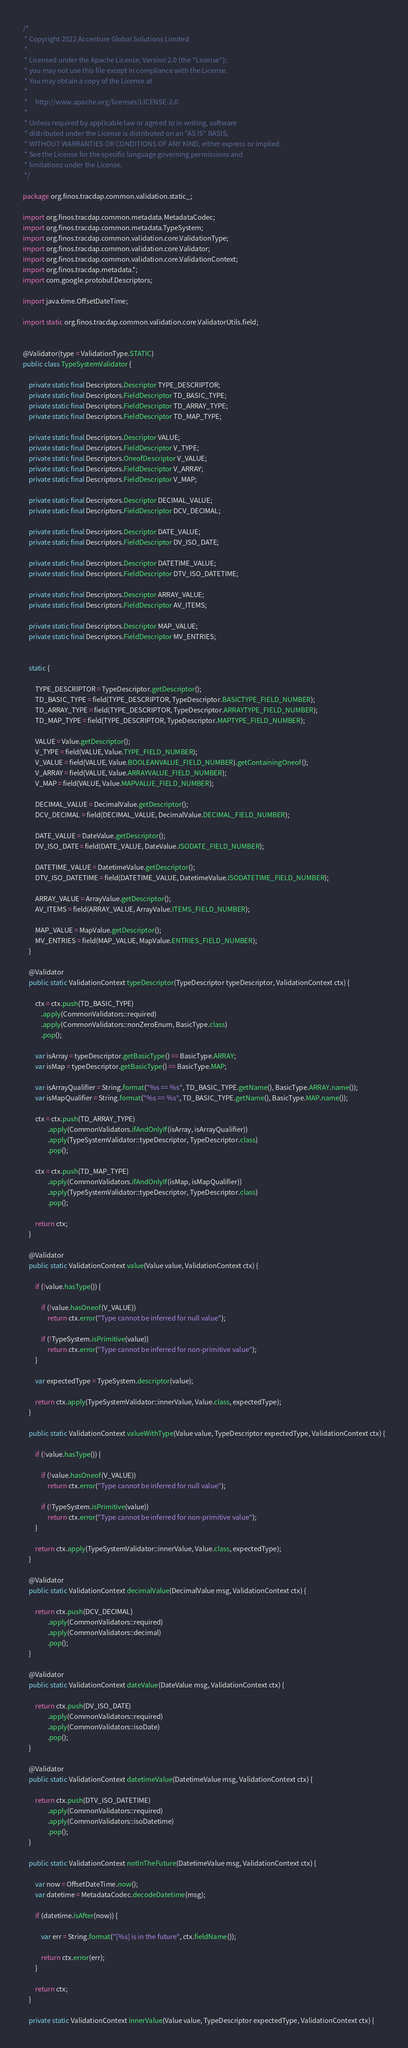Convert code to text. <code><loc_0><loc_0><loc_500><loc_500><_Java_>/*
 * Copyright 2022 Accenture Global Solutions Limited
 *
 * Licensed under the Apache License, Version 2.0 (the "License");
 * you may not use this file except in compliance with the License.
 * You may obtain a copy of the License at
 *
 *     http://www.apache.org/licenses/LICENSE-2.0
 *
 * Unless required by applicable law or agreed to in writing, software
 * distributed under the License is distributed on an "AS IS" BASIS,
 * WITHOUT WARRANTIES OR CONDITIONS OF ANY KIND, either express or implied.
 * See the License for the specific language governing permissions and
 * limitations under the License.
 */

package org.finos.tracdap.common.validation.static_;

import org.finos.tracdap.common.metadata.MetadataCodec;
import org.finos.tracdap.common.metadata.TypeSystem;
import org.finos.tracdap.common.validation.core.ValidationType;
import org.finos.tracdap.common.validation.core.Validator;
import org.finos.tracdap.common.validation.core.ValidationContext;
import org.finos.tracdap.metadata.*;
import com.google.protobuf.Descriptors;

import java.time.OffsetDateTime;

import static org.finos.tracdap.common.validation.core.ValidatorUtils.field;


@Validator(type = ValidationType.STATIC)
public class TypeSystemValidator {

    private static final Descriptors.Descriptor TYPE_DESCRIPTOR;
    private static final Descriptors.FieldDescriptor TD_BASIC_TYPE;
    private static final Descriptors.FieldDescriptor TD_ARRAY_TYPE;
    private static final Descriptors.FieldDescriptor TD_MAP_TYPE;

    private static final Descriptors.Descriptor VALUE;
    private static final Descriptors.FieldDescriptor V_TYPE;
    private static final Descriptors.OneofDescriptor V_VALUE;
    private static final Descriptors.FieldDescriptor V_ARRAY;
    private static final Descriptors.FieldDescriptor V_MAP;

    private static final Descriptors.Descriptor DECIMAL_VALUE;
    private static final Descriptors.FieldDescriptor DCV_DECIMAL;

    private static final Descriptors.Descriptor DATE_VALUE;
    private static final Descriptors.FieldDescriptor DV_ISO_DATE;

    private static final Descriptors.Descriptor DATETIME_VALUE;
    private static final Descriptors.FieldDescriptor DTV_ISO_DATETIME;

    private static final Descriptors.Descriptor ARRAY_VALUE;
    private static final Descriptors.FieldDescriptor AV_ITEMS;

    private static final Descriptors.Descriptor MAP_VALUE;
    private static final Descriptors.FieldDescriptor MV_ENTRIES;


    static {

        TYPE_DESCRIPTOR = TypeDescriptor.getDescriptor();
        TD_BASIC_TYPE = field(TYPE_DESCRIPTOR, TypeDescriptor.BASICTYPE_FIELD_NUMBER);
        TD_ARRAY_TYPE = field(TYPE_DESCRIPTOR, TypeDescriptor.ARRAYTYPE_FIELD_NUMBER);
        TD_MAP_TYPE = field(TYPE_DESCRIPTOR, TypeDescriptor.MAPTYPE_FIELD_NUMBER);

        VALUE = Value.getDescriptor();
        V_TYPE = field(VALUE, Value.TYPE_FIELD_NUMBER);
        V_VALUE = field(VALUE, Value.BOOLEANVALUE_FIELD_NUMBER).getContainingOneof();
        V_ARRAY = field(VALUE, Value.ARRAYVALUE_FIELD_NUMBER);
        V_MAP = field(VALUE, Value.MAPVALUE_FIELD_NUMBER);

        DECIMAL_VALUE = DecimalValue.getDescriptor();
        DCV_DECIMAL = field(DECIMAL_VALUE, DecimalValue.DECIMAL_FIELD_NUMBER);

        DATE_VALUE = DateValue.getDescriptor();
        DV_ISO_DATE = field(DATE_VALUE, DateValue.ISODATE_FIELD_NUMBER);

        DATETIME_VALUE = DatetimeValue.getDescriptor();
        DTV_ISO_DATETIME = field(DATETIME_VALUE, DatetimeValue.ISODATETIME_FIELD_NUMBER);

        ARRAY_VALUE = ArrayValue.getDescriptor();
        AV_ITEMS = field(ARRAY_VALUE, ArrayValue.ITEMS_FIELD_NUMBER);

        MAP_VALUE = MapValue.getDescriptor();
        MV_ENTRIES = field(MAP_VALUE, MapValue.ENTRIES_FIELD_NUMBER);
    }

    @Validator
    public static ValidationContext typeDescriptor(TypeDescriptor typeDescriptor, ValidationContext ctx) {

        ctx = ctx.push(TD_BASIC_TYPE)
            .apply(CommonValidators::required)
            .apply(CommonValidators::nonZeroEnum, BasicType.class)
            .pop();

        var isArray = typeDescriptor.getBasicType() == BasicType.ARRAY;
        var isMap = typeDescriptor.getBasicType() == BasicType.MAP;

        var isArrayQualifier = String.format("%s == %s", TD_BASIC_TYPE.getName(), BasicType.ARRAY.name());
        var isMapQualifier = String.format("%s == %s", TD_BASIC_TYPE.getName(), BasicType.MAP.name());

        ctx = ctx.push(TD_ARRAY_TYPE)
                .apply(CommonValidators.ifAndOnlyIf(isArray, isArrayQualifier))
                .apply(TypeSystemValidator::typeDescriptor, TypeDescriptor.class)
                .pop();

        ctx = ctx.push(TD_MAP_TYPE)
                .apply(CommonValidators.ifAndOnlyIf(isMap, isMapQualifier))
                .apply(TypeSystemValidator::typeDescriptor, TypeDescriptor.class)
                .pop();

        return ctx;
    }

    @Validator
    public static ValidationContext value(Value value, ValidationContext ctx) {

        if (!value.hasType()) {

            if (!value.hasOneof(V_VALUE))
                return ctx.error("Type cannot be inferred for null value");

            if (!TypeSystem.isPrimitive(value))
                return ctx.error("Type cannot be inferred for non-primitive value");
        }

        var expectedType = TypeSystem.descriptor(value);

        return ctx.apply(TypeSystemValidator::innerValue, Value.class, expectedType);
    }

    public static ValidationContext valueWithType(Value value, TypeDescriptor expectedType, ValidationContext ctx) {

        if (!value.hasType()) {

            if (!value.hasOneof(V_VALUE))
                return ctx.error("Type cannot be inferred for null value");

            if (!TypeSystem.isPrimitive(value))
                return ctx.error("Type cannot be inferred for non-primitive value");
        }

        return ctx.apply(TypeSystemValidator::innerValue, Value.class, expectedType);
    }

    @Validator
    public static ValidationContext decimalValue(DecimalValue msg, ValidationContext ctx) {

        return ctx.push(DCV_DECIMAL)
                .apply(CommonValidators::required)
                .apply(CommonValidators::decimal)
                .pop();
    }

    @Validator
    public static ValidationContext dateValue(DateValue msg, ValidationContext ctx) {

        return ctx.push(DV_ISO_DATE)
                .apply(CommonValidators::required)
                .apply(CommonValidators::isoDate)
                .pop();
    }

    @Validator
    public static ValidationContext datetimeValue(DatetimeValue msg, ValidationContext ctx) {

        return ctx.push(DTV_ISO_DATETIME)
                .apply(CommonValidators::required)
                .apply(CommonValidators::isoDatetime)
                .pop();
    }

    public static ValidationContext notInTheFuture(DatetimeValue msg, ValidationContext ctx) {

        var now = OffsetDateTime.now();
        var datetime = MetadataCodec.decodeDatetime(msg);

        if (datetime.isAfter(now)) {

            var err = String.format("[%s] is in the future", ctx.fieldName());

            return ctx.error(err);
        }

        return ctx;
    }

    private static ValidationContext innerValue(Value value, TypeDescriptor expectedType, ValidationContext ctx) {
</code> 